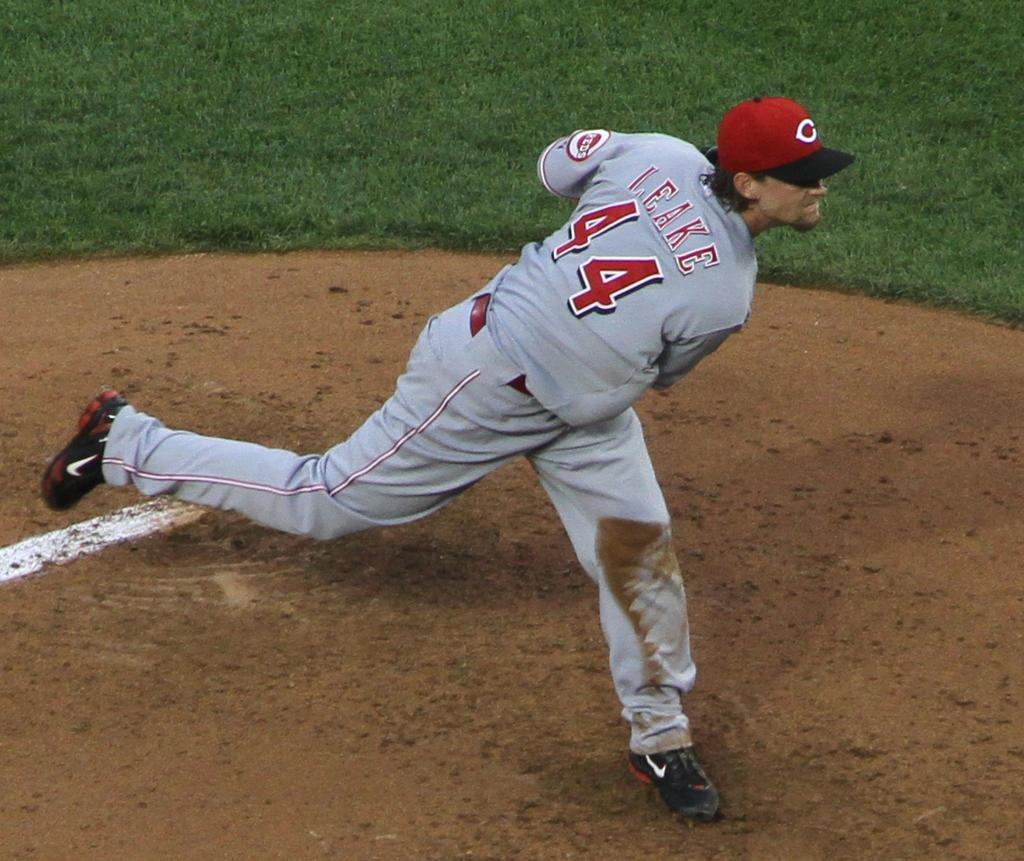Provide a one-sentence caption for the provided image. Cincinnati Reds pitcher Mike Leake at the end of his wind up after releasing a pitch. 